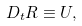<formula> <loc_0><loc_0><loc_500><loc_500>D _ { t } R \equiv U ,</formula> 